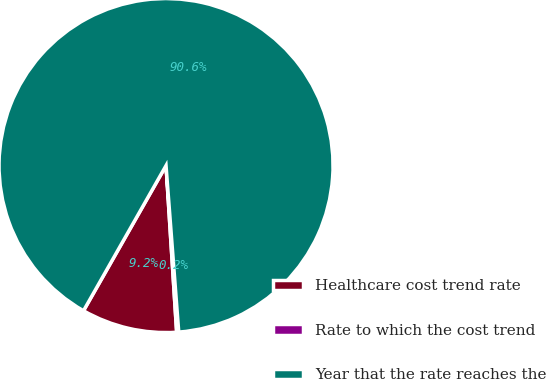Convert chart. <chart><loc_0><loc_0><loc_500><loc_500><pie_chart><fcel>Healthcare cost trend rate<fcel>Rate to which the cost trend<fcel>Year that the rate reaches the<nl><fcel>9.24%<fcel>0.2%<fcel>90.56%<nl></chart> 